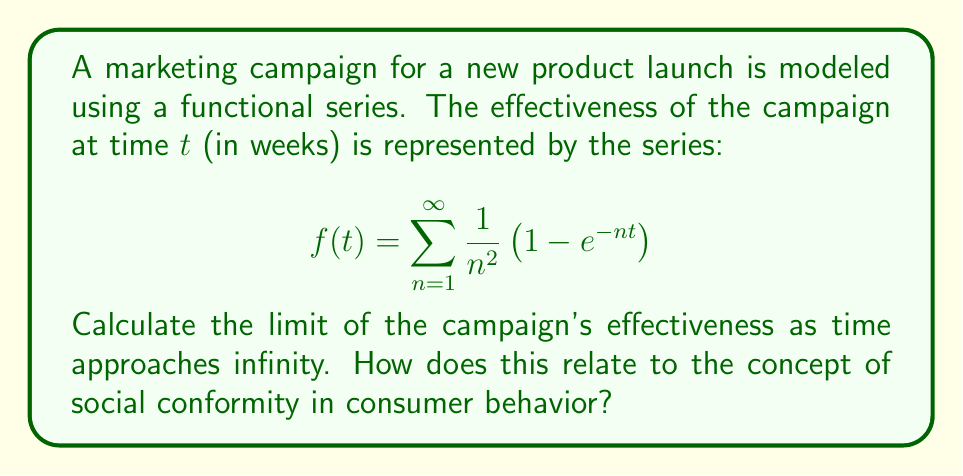Help me with this question. To solve this problem, we'll follow these steps:

1) First, we need to understand what happens to each term in the series as $t$ approaches infinity:

   $\lim_{t \to \infty} \frac{1}{n^2} \left(1 - e^{-nt}\right) = \frac{1}{n^2}$

   This is because $\lim_{t \to \infty} e^{-nt} = 0$ for any positive $n$.

2) So, as $t$ approaches infinity, our series becomes:

   $$\lim_{t \to \infty} f(t) = \sum_{n=1}^{\infty} \frac{1}{n^2}$$

3) This is a well-known series called the Basel problem. Its sum is:

   $$\sum_{n=1}^{\infty} \frac{1}{n^2} = \frac{\pi^2}{6}$$

4) Therefore, the limit of the campaign's effectiveness as time approaches infinity is $\frac{\pi^2}{6}$.

Relating this to social conformity in consumer behavior:

The series models how the campaign's effectiveness grows over time, eventually converging to a fixed value. This mirrors the concept of social conformity, where consumer behavior tends to align with social norms over time.

The fact that the series converges suggests that there's a maximum level of effectiveness for the campaign, beyond which additional time or effort won't significantly increase its impact. In terms of social conformity, this could represent the point where a product or behavior has become fully adopted by a community.

Each term in the series $\frac{1}{n^2} \left(1 - e^{-nt}\right)$ could represent the influence of different social groups or influencers, with larger values of $n$ representing groups with less impact (as $\frac{1}{n^2}$ decreases). The exponential term $e^{-nt}$ models how quickly each group adopts the product or behavior.
Answer: The limit of the campaign's effectiveness as time approaches infinity is $\frac{\pi^2}{6} \approx 1.6449$. 